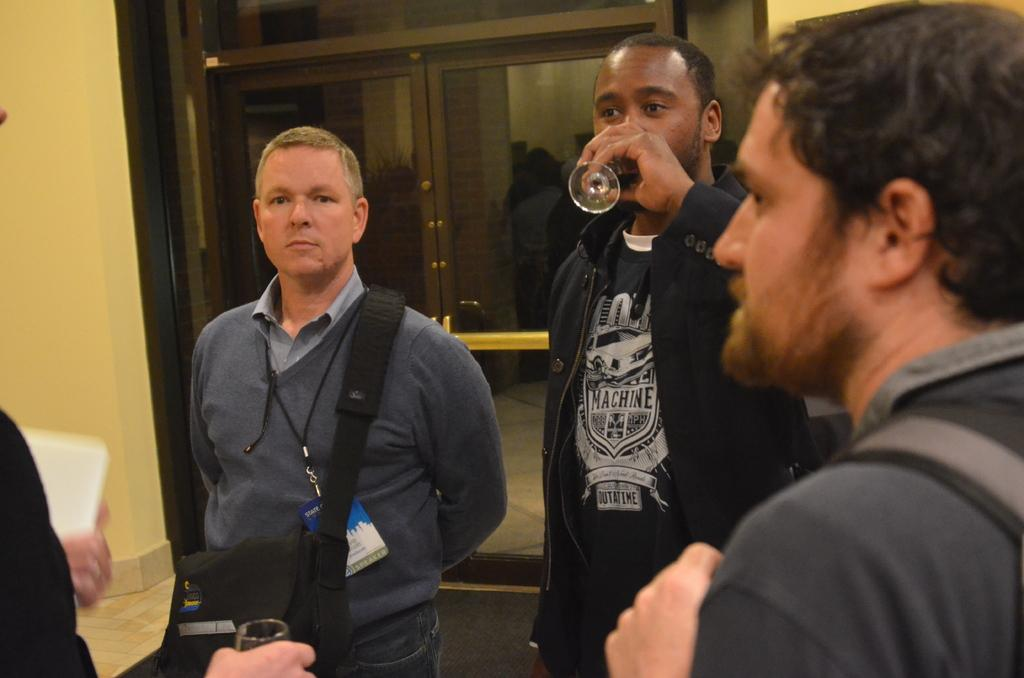How many people are in the image? There are three men in the image. Can you describe what one of the men is holding? One person is holding a glass in his hand. What can be seen in the background of the image? There are doors visible in the background of the image. What type of conversation is happening at the cemetery in the image? There is no cemetery present in the image, and therefore no conversation can be observed. 